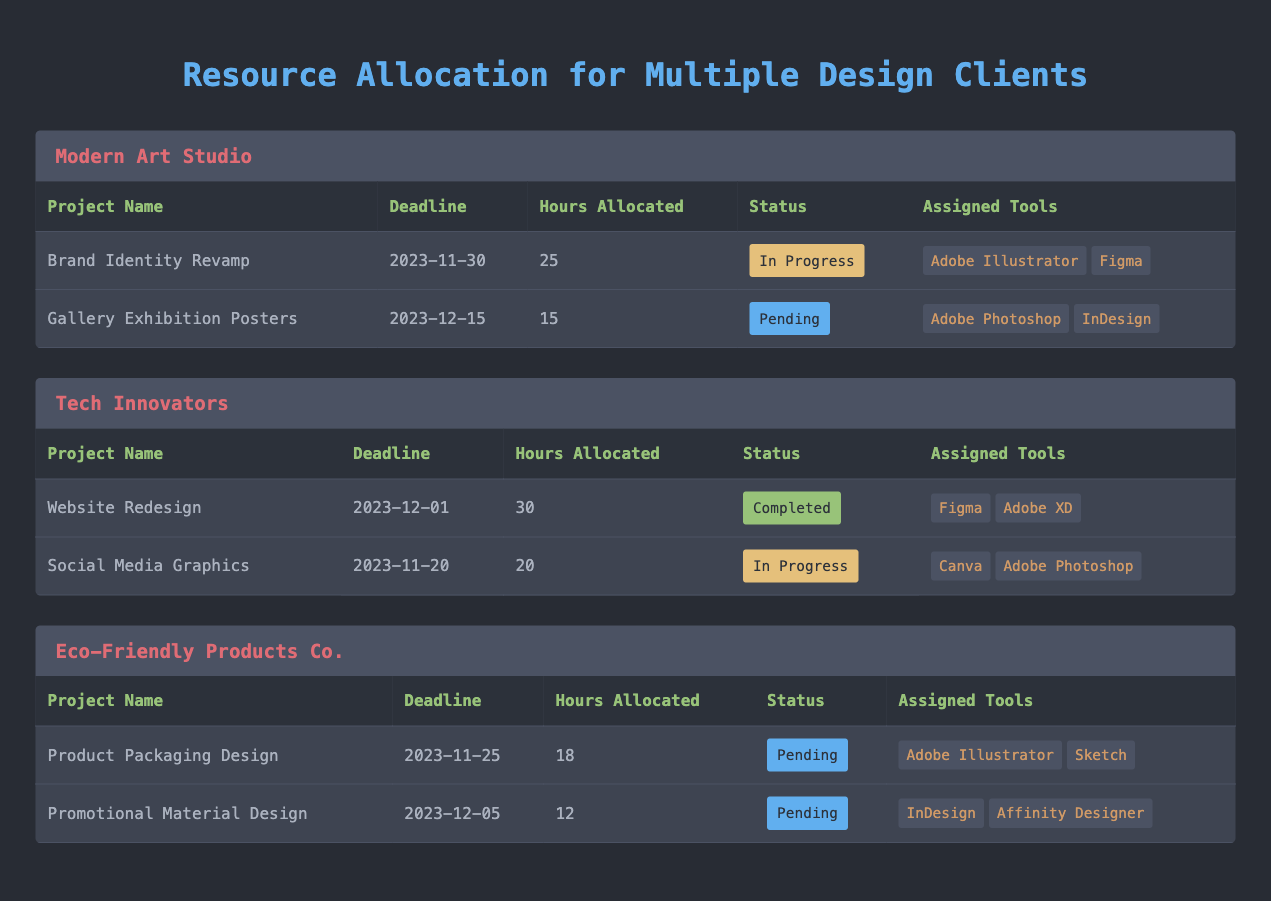What is the total number of hours allocated to all projects for Tech Innovators? The projects for Tech Innovators are “Website Redesign” with 30 hours allocated and “Social Media Graphics” with 20 hours allocated. Adding these together: 30 + 20 = 50 hours.
Answer: 50 Which project has the earliest deadline for Eco-Friendly Products Co.? Two projects are listed for Eco-Friendly Products Co.: “Product Packaging Design” with a deadline of 2023-11-25 and “Promotional Material Design” with a deadline of 2023-12-05. Comparing the deadlines, 2023-11-25 is earlier than 2023-12-05.
Answer: Product Packaging Design How many projects have a status of 'Pending'? In the provided data, we can see that “Gallery Exhibition Posters,” “Product Packaging Design,” and “Promotional Material Design” are marked as 'Pending'. This totals to 3 projects.
Answer: 3 Is there a project under Modern Art Studio that has been completed? Looking at the projects for Modern Art Studio, both projects noted—“Brand Identity Revamp” and “Gallery Exhibition Posters”—are either 'In Progress' or 'Pending,' with no completed projects present. Therefore, the answer is no.
Answer: No What is the total number of hours allocated to projects in progress across all clients? The in-progress projects are: "Brand Identity Revamp" (25 hours), "Social Media Graphics" (20 hours), for a total of 25 + 20 = 45 hours attributed to in-progress projects.
Answer: 45 Which client has the highest number of hours allocated in total? Calculating the total hours: Modern Art Studio (25 + 15 = 40), Tech Innovators (30 + 20 = 50), Eco-Friendly Products Co. (18 + 12 = 30). Tech Innovators has the highest total at 50 hours.
Answer: Tech Innovators What percentage of projects for Eco-Friendly Products Co. are pending? Eco-Friendly Products Co. has a total of 2 projects, both of which are pending. Calculating the percentage: (Number of pending projects / Total projects) × 100 = (2 / 2) × 100 = 100%.
Answer: 100% Are there any projects under Tech Innovators that use Adobe Photoshop? In the Tech Innovators projects, the project “Social Media Graphics” uses Adobe Photoshop while “Website Redesign” does not. Thus, yes, there is one project that utilizes Adobe Photoshop.
Answer: Yes 